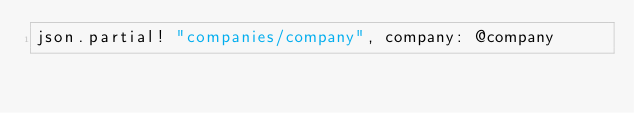Convert code to text. <code><loc_0><loc_0><loc_500><loc_500><_Ruby_>json.partial! "companies/company", company: @company
</code> 